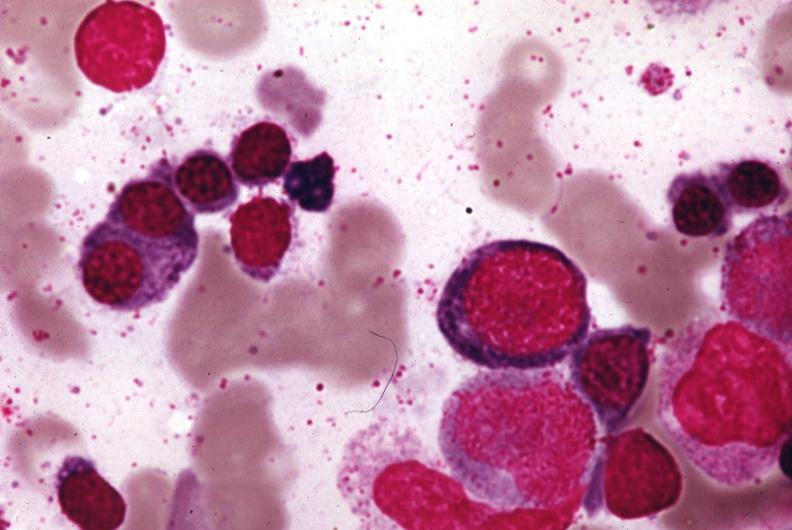what is present?
Answer the question using a single word or phrase. Hematologic 